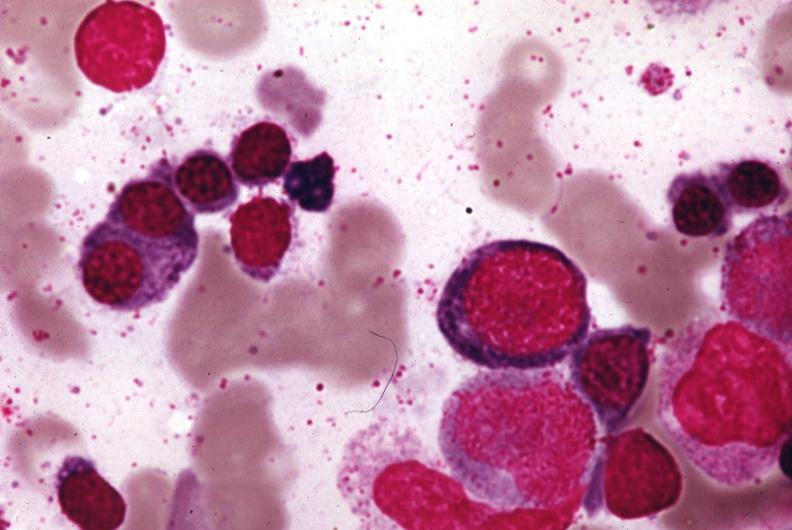what is present?
Answer the question using a single word or phrase. Hematologic 